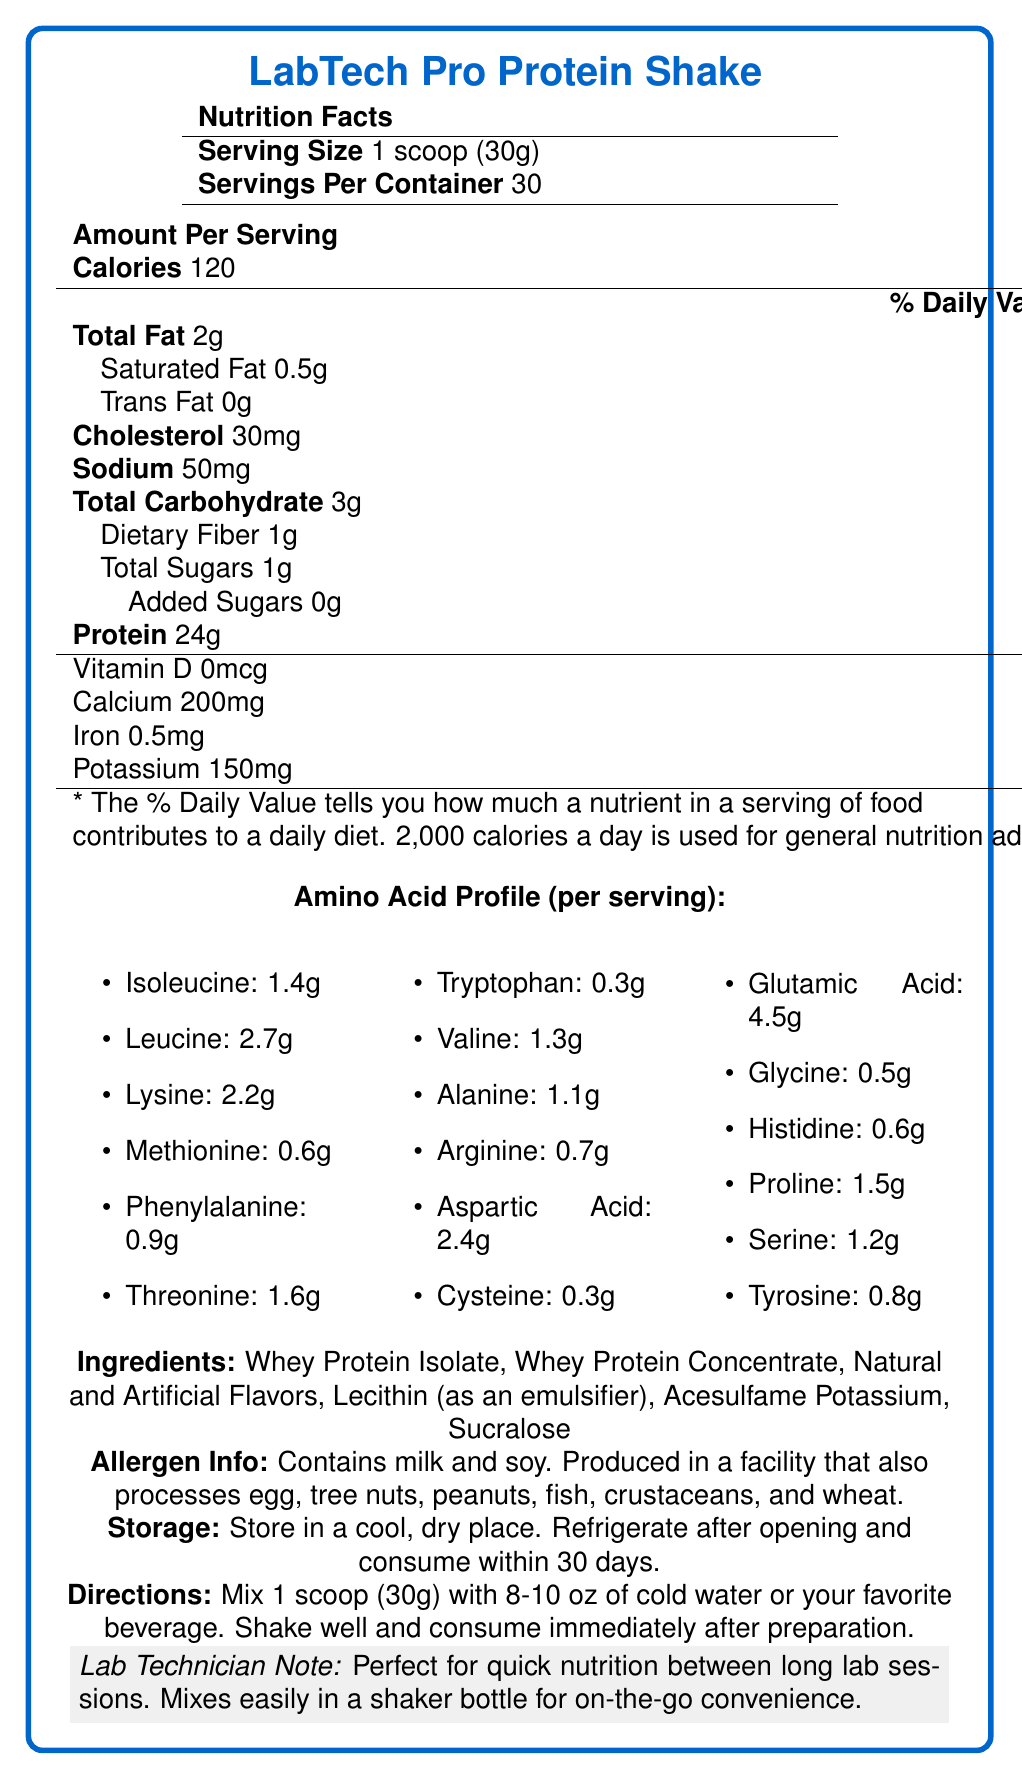what is the serving size? The document specifies the serving size as "1 scoop (30g)" under the Nutrition Facts section.
Answer: 1 scoop (30g) how many servings are in one container? The document states there are 30 servings per container in the Nutrition Facts section.
Answer: 30 servings how many calories are in one serving? The document lists "Calories 120" under the Amount Per Serving section.
Answer: 120 calories what is the total fat content per serving? The Total Fat content per serving is listed as "2g" with a daily value of 3%.
Answer: 2g what is the amount of protein per serving? The protein amount per serving is indicated as "Protein 24g" with a daily value of 48%.
Answer: 24g how much cholesterol is there per serving? The document mentions "Cholesterol 30mg" with a daily value of 10%.
Answer: 30mg how much sodium is in one serving? The document shows "Sodium 50mg" with a daily value of 2%.
Answer: 50mg how much dietary fiber is in one serving? The dietary fiber content is given as "Dietary Fiber 1g" with a daily value of 4%.
Answer: 1g how many amino acids are listed in the profile? The amino acid profile lists 17 different amino acids in the document.
Answer: 17 amino acids how many grams of isoleucine are in one serving? The amino acid profile section states that one serving contains "Isoleucine: 1.4g".
Answer: 1.4g what equipment is suggested for mixing the shake? The lab technician note mentions that the product "mixes easily in a shaker bottle for on-the-go convenience."
Answer: Shaker bottle what are two main ingredients of the protein shake? A. Whey Protein Isolate and Whey Protein Concentrate B. Artificial Flavors and Lecithin C. Acesulfame Potassium and Sucralose The main ingredients listed are "Whey Protein Isolate" and "Whey Protein Concentrate." Other ingredients follow these.
Answer: A. Whey Protein Isolate and Whey Protein Concentrate how much leucine does the shake provide per serving? 1. 1.4g 2. 2.2g 3. 2.7g 4. 3.0g The amino acid profile states that one serving contains "Leucine: 2.7g."
Answer: 3. 2.7g is there any vitamin D in the protein shake? The document shows "Vitamin D 0mcg" with a daily value of 0%.
Answer: No is the product safe for someone who is allergic to milk? The allergen info clearly states "Contains milk and soy," indicating it is not safe for those allergic to milk.
Answer: No summarize the main nutritional features of the LabTech Pro Protein Shake. The summary captures the key nutritional aspects and major ingredients of the protein shake, as well as important allergen information as described in the document.
Answer: The LabTech Pro Protein Shake provides 120 calories per serving with 2g of total fat, 3g of carbohydrates, and 24g of protein. It contains essential vitamins and minerals, an extensive amino acid profile, and is made primarily of whey protein isolate and concentrate. Allergen information indicates the presence of milk and soy. which flavor is used in this protein shake? The document mentions "Natural and Artificial Flavors" but does not specify the exact flavor used.
Answer: Not enough information 